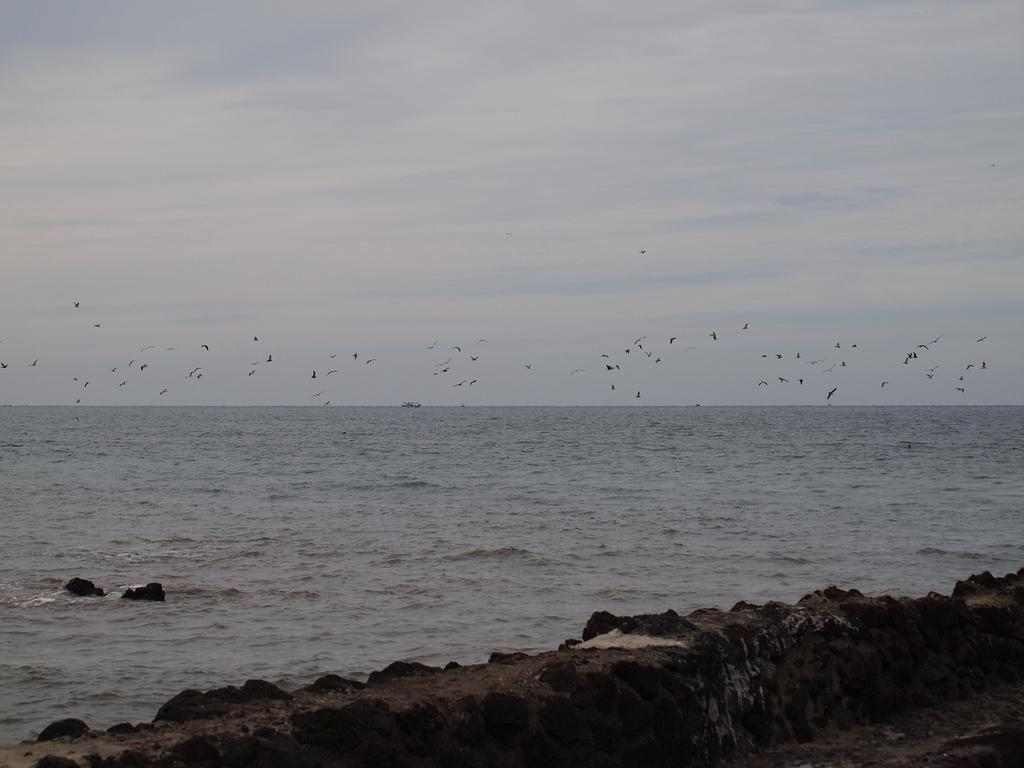What is the primary subject of the image? The image consists of an ocean. What can be seen in the water? There is water visible in the image. What is flying in the air in the image? Birds are flying in the air in the image. What is visible in the sky? There are clouds in the sky in the image. What is present at the bottom of the image? Rocks are present at the bottom of the image. What type of silver is being used to make the cheese in the image? There is no silver or cheese present in the image; it features an ocean, birds, clouds, and rocks. What religious symbols can be seen in the image? There are no religious symbols present in the image; it features an ocean, birds, clouds, and rocks. 